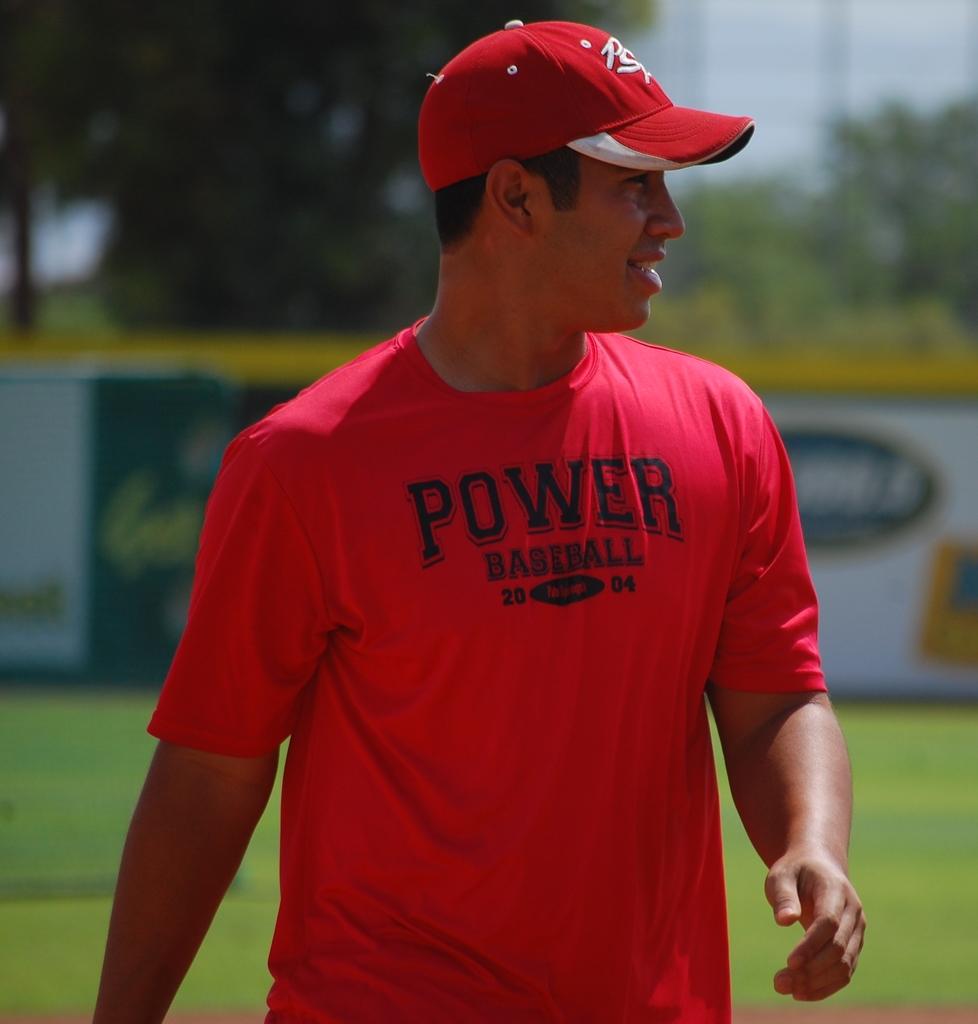What does the man's shirt say in large capital letters?
Keep it short and to the point. Power. 